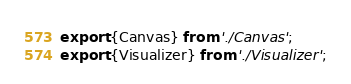<code> <loc_0><loc_0><loc_500><loc_500><_JavaScript_>export {Canvas} from './Canvas';
export {Visualizer} from './Visualizer';</code> 